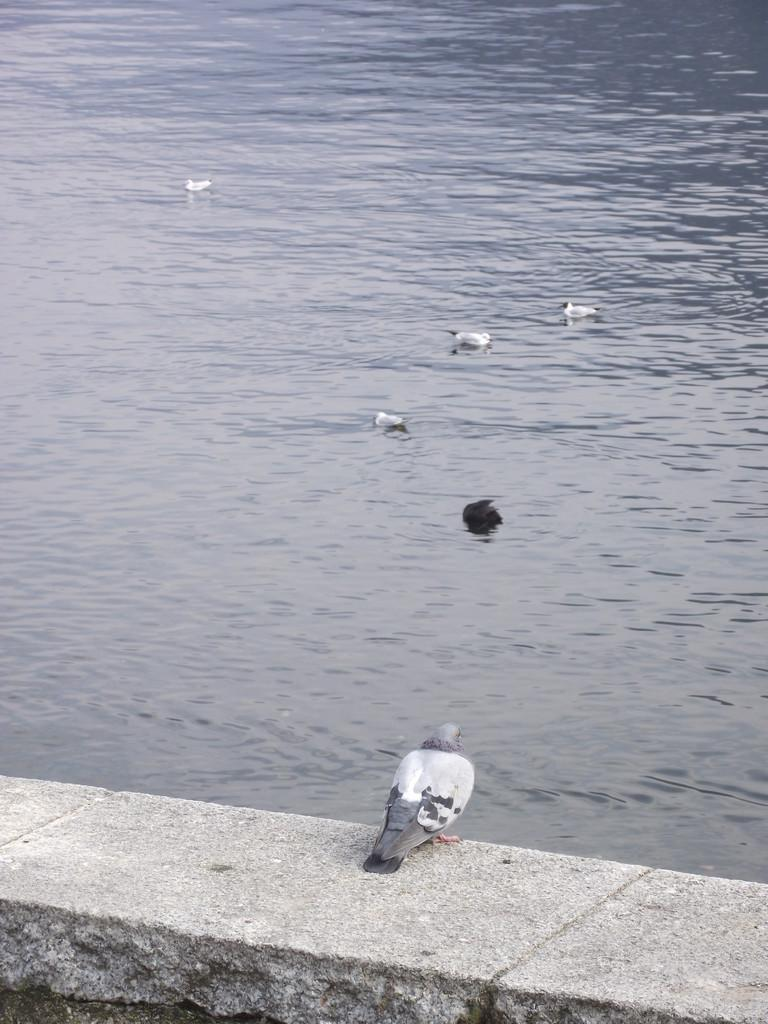What type of animal is in the image? There is a bird in the image. Can you describe the bird's coloring? The bird has gray and black colors. What is happening in the background of the image? There are birds in the water in the background of the image. What type of beam is holding up the cake in the image? There is no cake or beam present in the image; it features a bird with gray and black colors, and birds in the water in the background. 